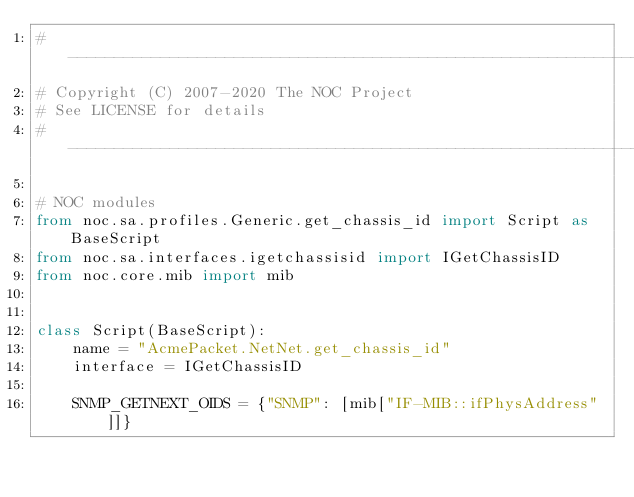<code> <loc_0><loc_0><loc_500><loc_500><_Python_># ----------------------------------------------------------------------
# Copyright (C) 2007-2020 The NOC Project
# See LICENSE for details
# ----------------------------------------------------------------------

# NOC modules
from noc.sa.profiles.Generic.get_chassis_id import Script as BaseScript
from noc.sa.interfaces.igetchassisid import IGetChassisID
from noc.core.mib import mib


class Script(BaseScript):
    name = "AcmePacket.NetNet.get_chassis_id"
    interface = IGetChassisID

    SNMP_GETNEXT_OIDS = {"SNMP": [mib["IF-MIB::ifPhysAddress"]]}
</code> 